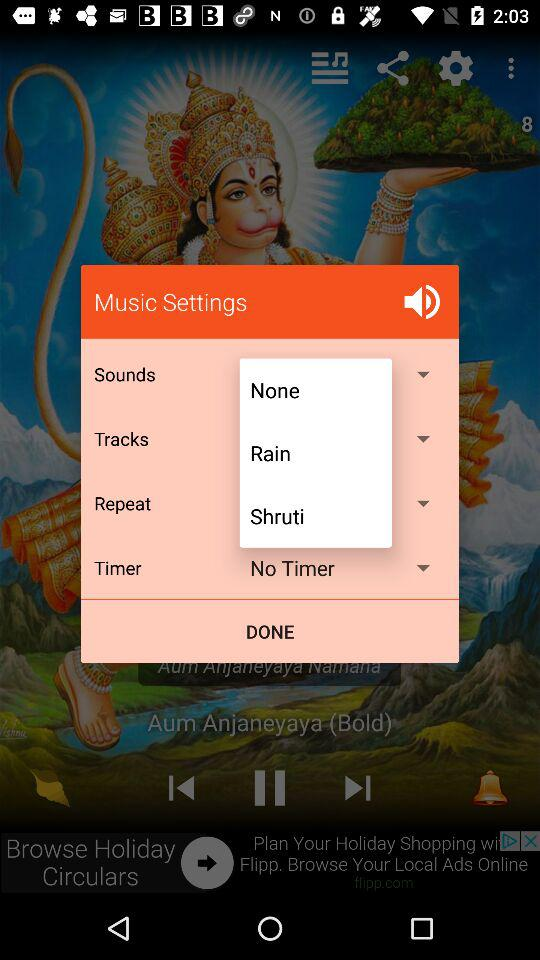What is the tracks sound? The tracks sound is "Rain". 